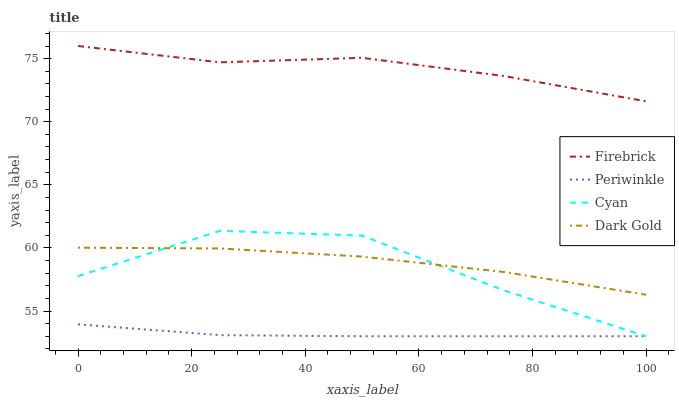Does Periwinkle have the minimum area under the curve?
Answer yes or no. Yes. Does Firebrick have the maximum area under the curve?
Answer yes or no. Yes. Does Firebrick have the minimum area under the curve?
Answer yes or no. No. Does Periwinkle have the maximum area under the curve?
Answer yes or no. No. Is Periwinkle the smoothest?
Answer yes or no. Yes. Is Cyan the roughest?
Answer yes or no. Yes. Is Firebrick the smoothest?
Answer yes or no. No. Is Firebrick the roughest?
Answer yes or no. No. Does Firebrick have the lowest value?
Answer yes or no. No. Does Firebrick have the highest value?
Answer yes or no. Yes. Does Periwinkle have the highest value?
Answer yes or no. No. Is Cyan less than Firebrick?
Answer yes or no. Yes. Is Firebrick greater than Periwinkle?
Answer yes or no. Yes. Does Cyan intersect Firebrick?
Answer yes or no. No. 